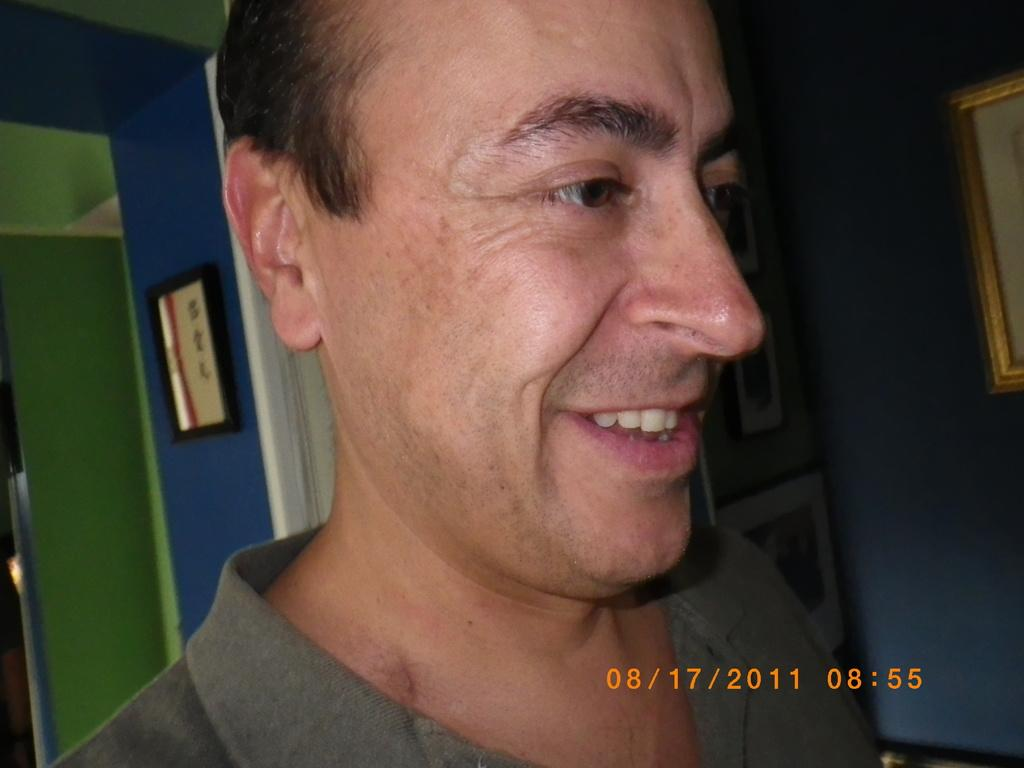Who is the main subject in the image? There is a person in the center of the image. What is the person doing in the image? The person is smiling. What can be seen in the background of the image? There is a wall, a roof, and photo frames in the background of the image. What type of cake is being rewarded to the person in the image? There is no cake or reward present in the image. Is the person on a swing in the image? There is no swing present in the image. 